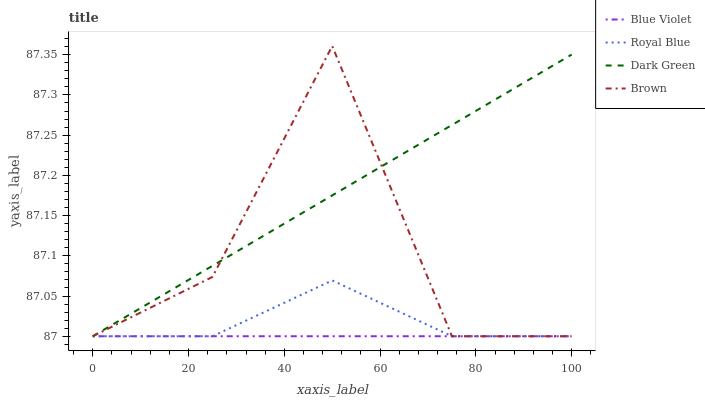Does Blue Violet have the minimum area under the curve?
Answer yes or no. Yes. Does Dark Green have the maximum area under the curve?
Answer yes or no. Yes. Does Brown have the minimum area under the curve?
Answer yes or no. No. Does Brown have the maximum area under the curve?
Answer yes or no. No. Is Blue Violet the smoothest?
Answer yes or no. Yes. Is Brown the roughest?
Answer yes or no. Yes. Is Brown the smoothest?
Answer yes or no. No. Is Blue Violet the roughest?
Answer yes or no. No. Does Royal Blue have the lowest value?
Answer yes or no. Yes. Does Brown have the highest value?
Answer yes or no. Yes. Does Blue Violet have the highest value?
Answer yes or no. No. Does Brown intersect Blue Violet?
Answer yes or no. Yes. Is Brown less than Blue Violet?
Answer yes or no. No. Is Brown greater than Blue Violet?
Answer yes or no. No. 